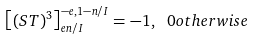Convert formula to latex. <formula><loc_0><loc_0><loc_500><loc_500>\left [ ( S T ) ^ { 3 } \right ] _ { e n / I } ^ { - e , 1 - n / I } = - 1 , \ 0 o t h e r w i s e</formula> 